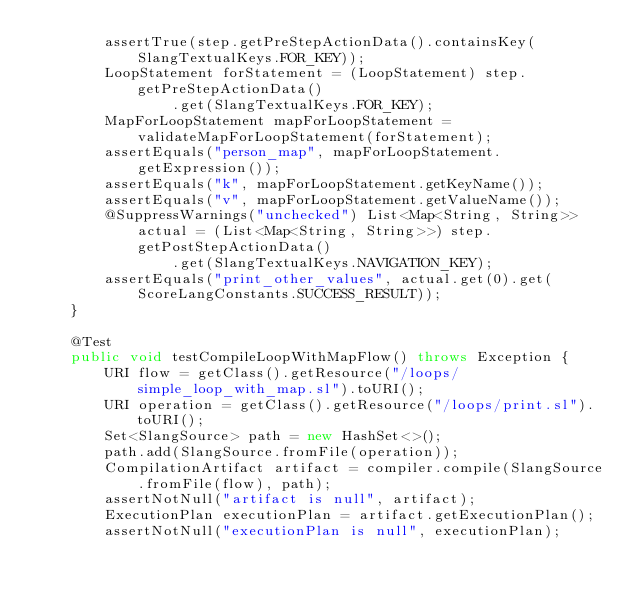Convert code to text. <code><loc_0><loc_0><loc_500><loc_500><_Java_>        assertTrue(step.getPreStepActionData().containsKey(SlangTextualKeys.FOR_KEY));
        LoopStatement forStatement = (LoopStatement) step.getPreStepActionData()
                .get(SlangTextualKeys.FOR_KEY);
        MapForLoopStatement mapForLoopStatement = validateMapForLoopStatement(forStatement);
        assertEquals("person_map", mapForLoopStatement.getExpression());
        assertEquals("k", mapForLoopStatement.getKeyName());
        assertEquals("v", mapForLoopStatement.getValueName());
        @SuppressWarnings("unchecked") List<Map<String, String>> actual = (List<Map<String, String>>) step.getPostStepActionData()
                .get(SlangTextualKeys.NAVIGATION_KEY);
        assertEquals("print_other_values", actual.get(0).get(ScoreLangConstants.SUCCESS_RESULT));
    }

    @Test
    public void testCompileLoopWithMapFlow() throws Exception {
        URI flow = getClass().getResource("/loops/simple_loop_with_map.sl").toURI();
        URI operation = getClass().getResource("/loops/print.sl").toURI();
        Set<SlangSource> path = new HashSet<>();
        path.add(SlangSource.fromFile(operation));
        CompilationArtifact artifact = compiler.compile(SlangSource.fromFile(flow), path);
        assertNotNull("artifact is null", artifact);
        ExecutionPlan executionPlan = artifact.getExecutionPlan();
        assertNotNull("executionPlan is null", executionPlan);</code> 